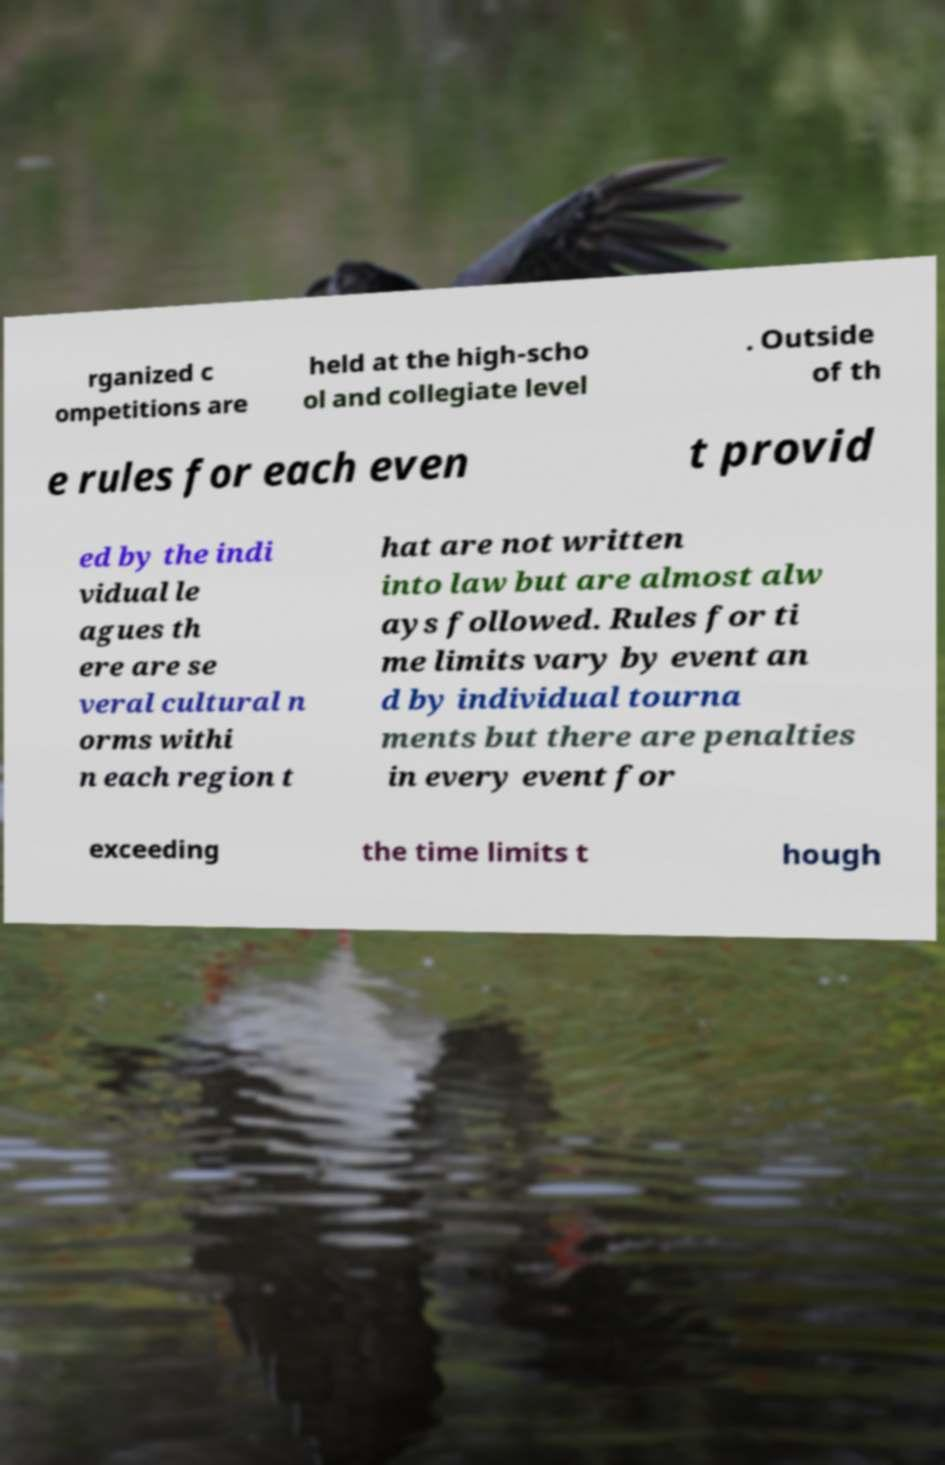There's text embedded in this image that I need extracted. Can you transcribe it verbatim? rganized c ompetitions are held at the high-scho ol and collegiate level . Outside of th e rules for each even t provid ed by the indi vidual le agues th ere are se veral cultural n orms withi n each region t hat are not written into law but are almost alw ays followed. Rules for ti me limits vary by event an d by individual tourna ments but there are penalties in every event for exceeding the time limits t hough 